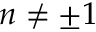Convert formula to latex. <formula><loc_0><loc_0><loc_500><loc_500>n \neq \pm 1</formula> 